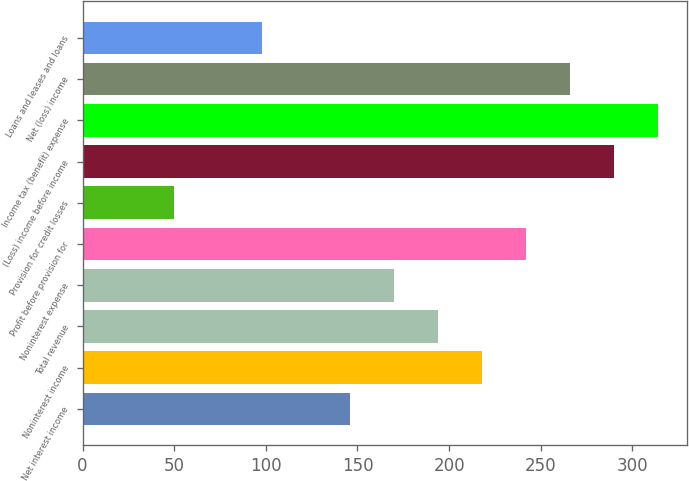Convert chart. <chart><loc_0><loc_0><loc_500><loc_500><bar_chart><fcel>Net interest income<fcel>Noninterest income<fcel>Total revenue<fcel>Noninterest expense<fcel>Profit before provision for<fcel>Provision for credit losses<fcel>(Loss) income before income<fcel>Income tax (benefit) expense<fcel>Net (loss) income<fcel>Loans and leases and loans<nl><fcel>146<fcel>218<fcel>194<fcel>170<fcel>242<fcel>50<fcel>290<fcel>314<fcel>266<fcel>98<nl></chart> 